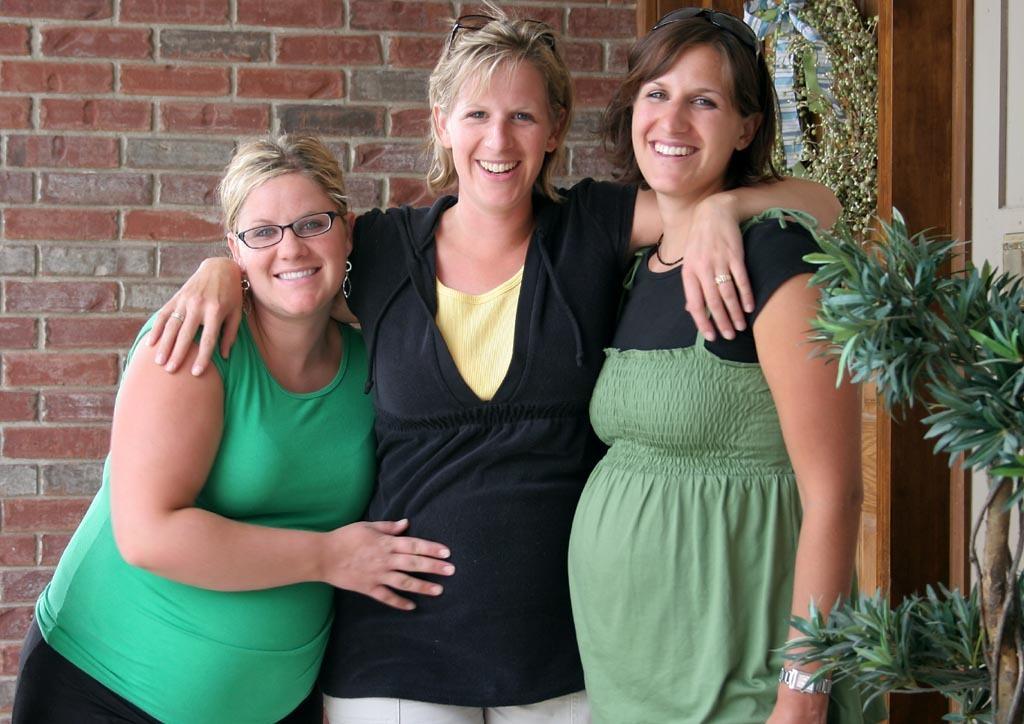In one or two sentences, can you explain what this image depicts? In the picture there are three women standing together and laughing, behind them there is a wall, there are plants. 